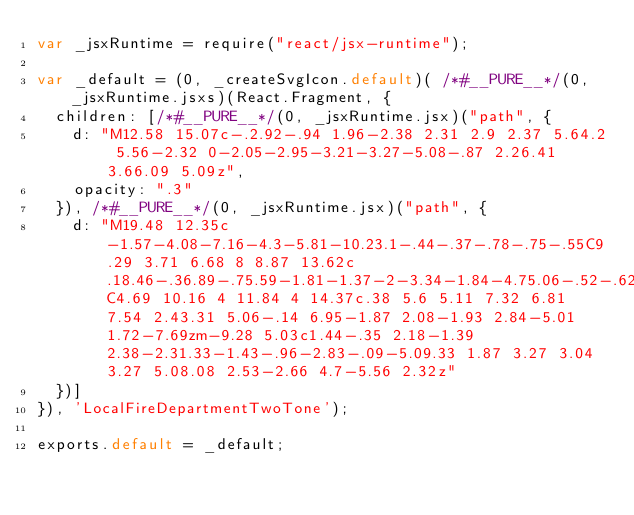<code> <loc_0><loc_0><loc_500><loc_500><_JavaScript_>var _jsxRuntime = require("react/jsx-runtime");

var _default = (0, _createSvgIcon.default)( /*#__PURE__*/(0, _jsxRuntime.jsxs)(React.Fragment, {
  children: [/*#__PURE__*/(0, _jsxRuntime.jsx)("path", {
    d: "M12.58 15.07c-.2.92-.94 1.96-2.38 2.31 2.9 2.37 5.64.2 5.56-2.32 0-2.05-2.95-3.21-3.27-5.08-.87 2.26.41 3.66.09 5.09z",
    opacity: ".3"
  }), /*#__PURE__*/(0, _jsxRuntime.jsx)("path", {
    d: "M19.48 12.35c-1.57-4.08-7.16-4.3-5.81-10.23.1-.44-.37-.78-.75-.55C9.29 3.71 6.68 8 8.87 13.62c.18.46-.36.89-.75.59-1.81-1.37-2-3.34-1.84-4.75.06-.52-.62-.77-.91-.34C4.69 10.16 4 11.84 4 14.37c.38 5.6 5.11 7.32 6.81 7.54 2.43.31 5.06-.14 6.95-1.87 2.08-1.93 2.84-5.01 1.72-7.69zm-9.28 5.03c1.44-.35 2.18-1.39 2.38-2.31.33-1.43-.96-2.83-.09-5.09.33 1.87 3.27 3.04 3.27 5.08.08 2.53-2.66 4.7-5.56 2.32z"
  })]
}), 'LocalFireDepartmentTwoTone');

exports.default = _default;</code> 